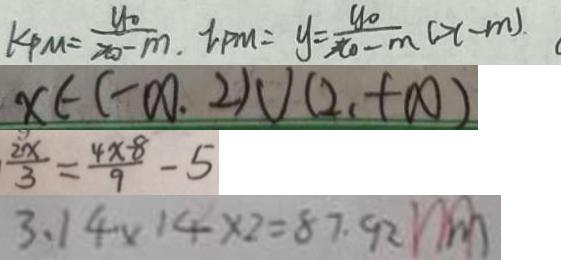<formula> <loc_0><loc_0><loc_500><loc_500>k P M = \frac { y _ { 0 } } { x _ { 0 } - m . } l _ { P M } = y = \frac { y _ { 0 } } { x _ { 0 } - m } ( x - m ) 
 x \in ( - \infty . 2 ) \cup ( 2 、 + \infty ) 
 \frac { 2 x } { 3 } = \frac { 4 x - 8 } { 9 } - 5 
 3 . 1 4 \times 1 4 \times 2 = 8 7 . 9 2 ( m )</formula> 